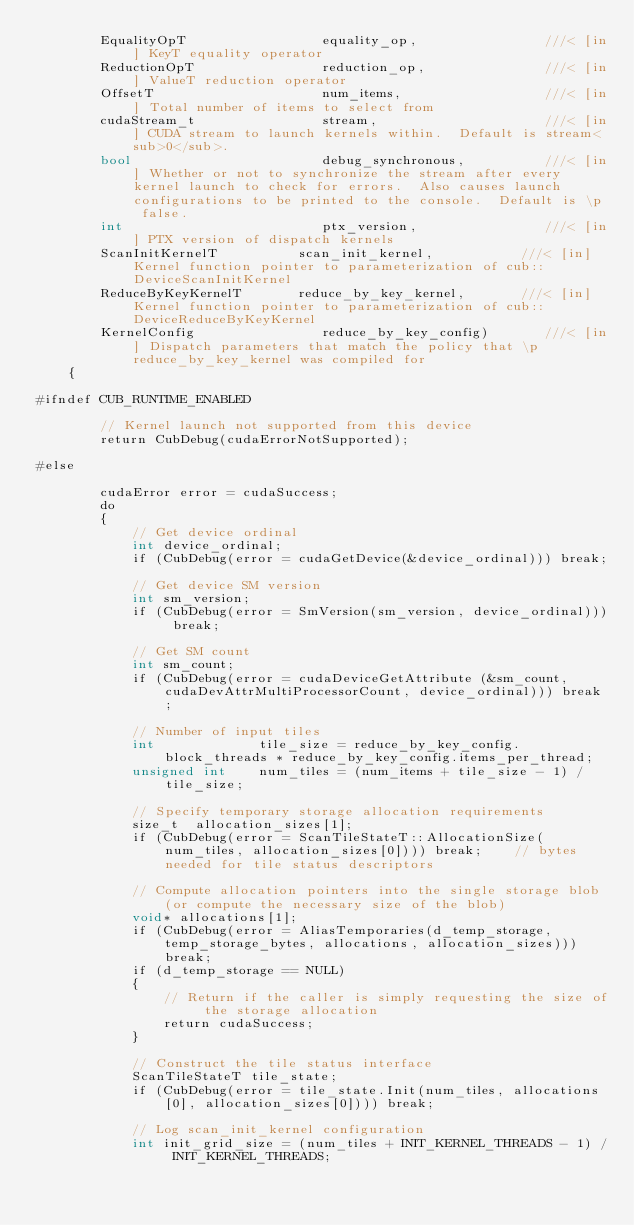<code> <loc_0><loc_0><loc_500><loc_500><_Cuda_>        EqualityOpT                 equality_op,                ///< [in] KeyT equality operator
        ReductionOpT                reduction_op,               ///< [in] ValueT reduction operator
        OffsetT                     num_items,                  ///< [in] Total number of items to select from
        cudaStream_t                stream,                     ///< [in] CUDA stream to launch kernels within.  Default is stream<sub>0</sub>.
        bool                        debug_synchronous,          ///< [in] Whether or not to synchronize the stream after every kernel launch to check for errors.  Also causes launch configurations to be printed to the console.  Default is \p false.
        int                         ptx_version,                ///< [in] PTX version of dispatch kernels
        ScanInitKernelT          scan_init_kernel,           ///< [in] Kernel function pointer to parameterization of cub::DeviceScanInitKernel
        ReduceByKeyKernelT       reduce_by_key_kernel,       ///< [in] Kernel function pointer to parameterization of cub::DeviceReduceByKeyKernel
        KernelConfig                reduce_by_key_config)       ///< [in] Dispatch parameters that match the policy that \p reduce_by_key_kernel was compiled for
    {

#ifndef CUB_RUNTIME_ENABLED

        // Kernel launch not supported from this device
        return CubDebug(cudaErrorNotSupported);

#else

        cudaError error = cudaSuccess;
        do
        {
            // Get device ordinal
            int device_ordinal;
            if (CubDebug(error = cudaGetDevice(&device_ordinal))) break;

            // Get device SM version
            int sm_version;
            if (CubDebug(error = SmVersion(sm_version, device_ordinal))) break;

            // Get SM count
            int sm_count;
            if (CubDebug(error = cudaDeviceGetAttribute (&sm_count, cudaDevAttrMultiProcessorCount, device_ordinal))) break;

            // Number of input tiles
            int             tile_size = reduce_by_key_config.block_threads * reduce_by_key_config.items_per_thread;
            unsigned int    num_tiles = (num_items + tile_size - 1) / tile_size;

            // Specify temporary storage allocation requirements
            size_t  allocation_sizes[1];
            if (CubDebug(error = ScanTileStateT::AllocationSize(num_tiles, allocation_sizes[0]))) break;    // bytes needed for tile status descriptors

            // Compute allocation pointers into the single storage blob (or compute the necessary size of the blob)
            void* allocations[1];
            if (CubDebug(error = AliasTemporaries(d_temp_storage, temp_storage_bytes, allocations, allocation_sizes))) break;
            if (d_temp_storage == NULL)
            {
                // Return if the caller is simply requesting the size of the storage allocation
                return cudaSuccess;
            }

            // Construct the tile status interface
            ScanTileStateT tile_state;
            if (CubDebug(error = tile_state.Init(num_tiles, allocations[0], allocation_sizes[0]))) break;

            // Log scan_init_kernel configuration
            int init_grid_size = (num_tiles + INIT_KERNEL_THREADS - 1) / INIT_KERNEL_THREADS;</code> 